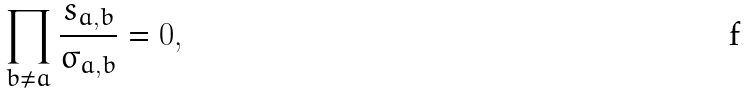<formula> <loc_0><loc_0><loc_500><loc_500>\prod _ { b \neq a } \frac { s _ { a , b } } { \sigma _ { a , b } } = 0 ,</formula> 